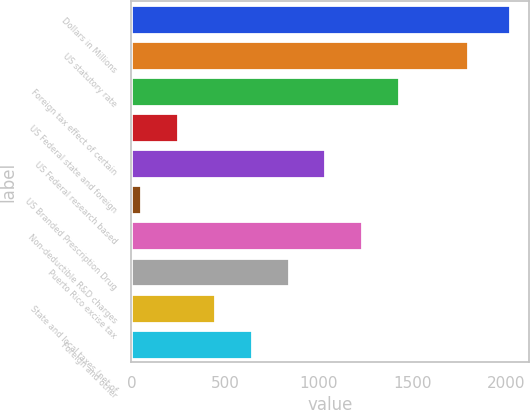Convert chart to OTSL. <chart><loc_0><loc_0><loc_500><loc_500><bar_chart><fcel>Dollars in Millions<fcel>US statutory rate<fcel>Foreign tax effect of certain<fcel>US Federal state and foreign<fcel>US Federal research based<fcel>US Branded Prescription Drug<fcel>Non-deductible R&D charges<fcel>Puerto Rico excise tax<fcel>State and local taxes (net of<fcel>Foreign and other<nl><fcel>2017<fcel>1796<fcel>1427.5<fcel>248.5<fcel>1034.5<fcel>52<fcel>1231<fcel>838<fcel>445<fcel>641.5<nl></chart> 